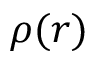Convert formula to latex. <formula><loc_0><loc_0><loc_500><loc_500>\rho ( r )</formula> 